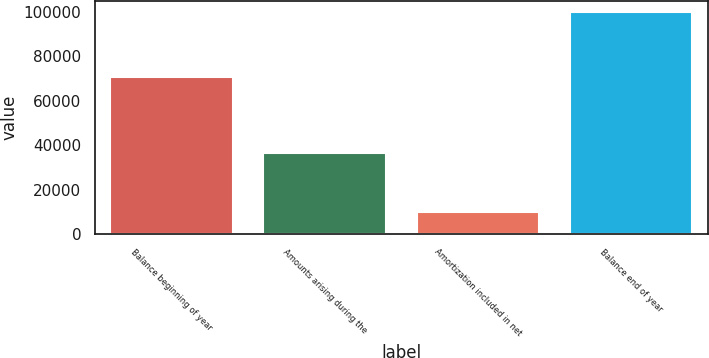<chart> <loc_0><loc_0><loc_500><loc_500><bar_chart><fcel>Balance beginning of year<fcel>Amounts arising during the<fcel>Amortization included in net<fcel>Balance end of year<nl><fcel>70803<fcel>36451<fcel>9827<fcel>99813<nl></chart> 